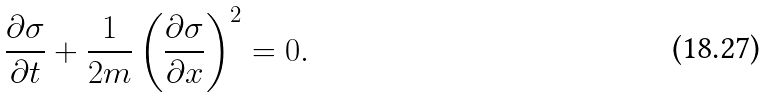Convert formula to latex. <formula><loc_0><loc_0><loc_500><loc_500>\frac { \partial \sigma } { \partial t } + \frac { 1 } { 2 m } \left ( \frac { \partial \sigma } { \partial x } \right ) ^ { 2 } = 0 .</formula> 